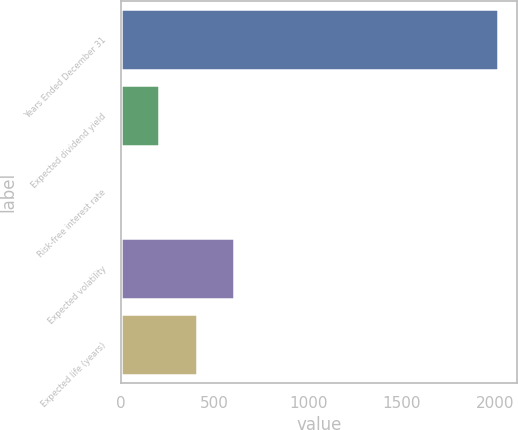Convert chart to OTSL. <chart><loc_0><loc_0><loc_500><loc_500><bar_chart><fcel>Years Ended December 31<fcel>Expected dividend yield<fcel>Risk-free interest rate<fcel>Expected volatility<fcel>Expected life (years)<nl><fcel>2013<fcel>202.38<fcel>1.2<fcel>604.74<fcel>403.56<nl></chart> 